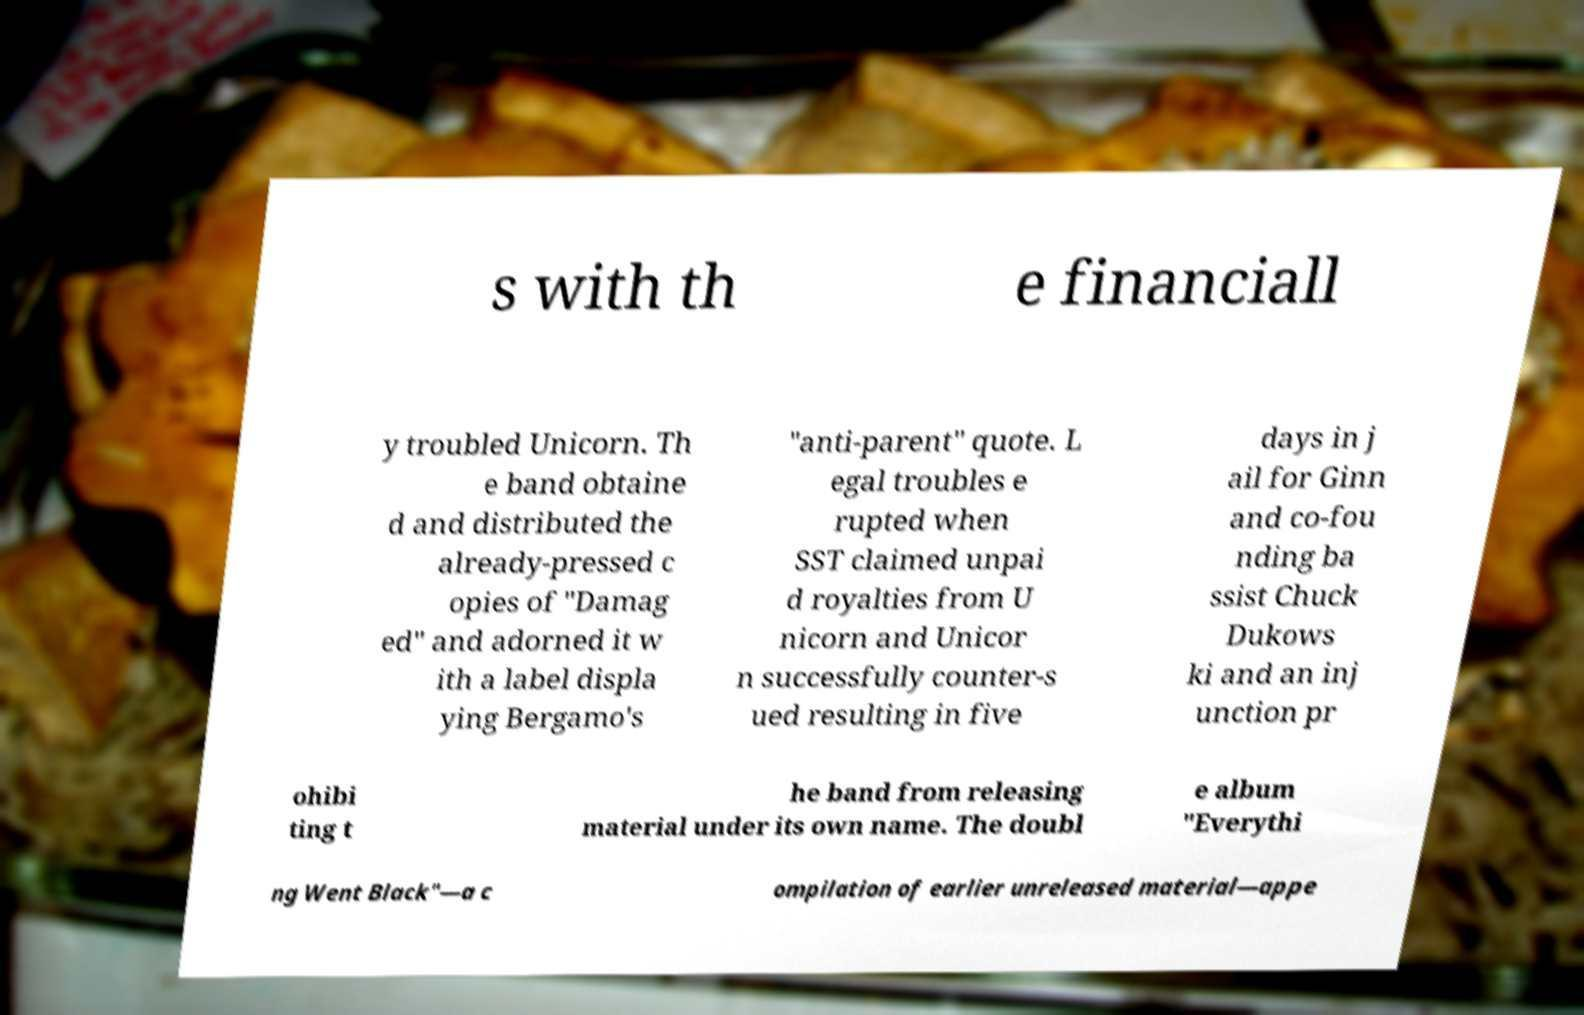There's text embedded in this image that I need extracted. Can you transcribe it verbatim? s with th e financiall y troubled Unicorn. Th e band obtaine d and distributed the already-pressed c opies of "Damag ed" and adorned it w ith a label displa ying Bergamo's "anti-parent" quote. L egal troubles e rupted when SST claimed unpai d royalties from U nicorn and Unicor n successfully counter-s ued resulting in five days in j ail for Ginn and co-fou nding ba ssist Chuck Dukows ki and an inj unction pr ohibi ting t he band from releasing material under its own name. The doubl e album "Everythi ng Went Black"—a c ompilation of earlier unreleased material—appe 